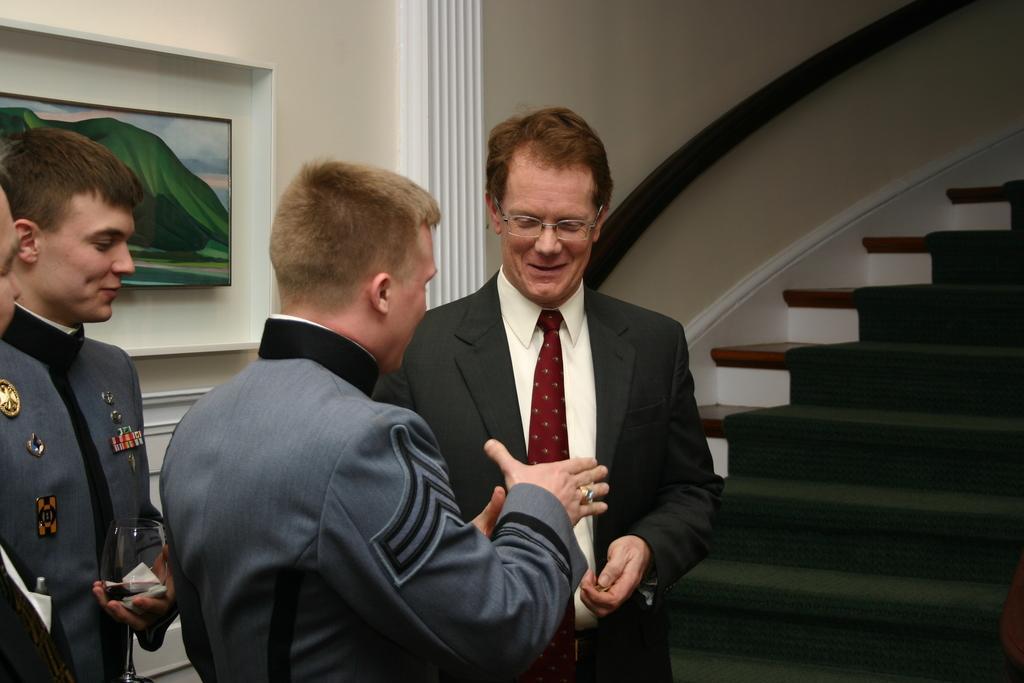Can you describe this image briefly? There are some people standing. Person in black suit is wearing a specs. Person on the left side is having badges on the suit. He is holding a glass with a tissue. In the back there's a wall with a photo frame. On the right side there is a staircase. 